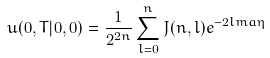<formula> <loc_0><loc_0><loc_500><loc_500>u ( 0 , T | 0 , 0 ) = \frac { 1 } { 2 ^ { 2 n } } \sum _ { l = 0 } ^ { n } J ( n , l ) e ^ { - 2 l m a \eta }</formula> 